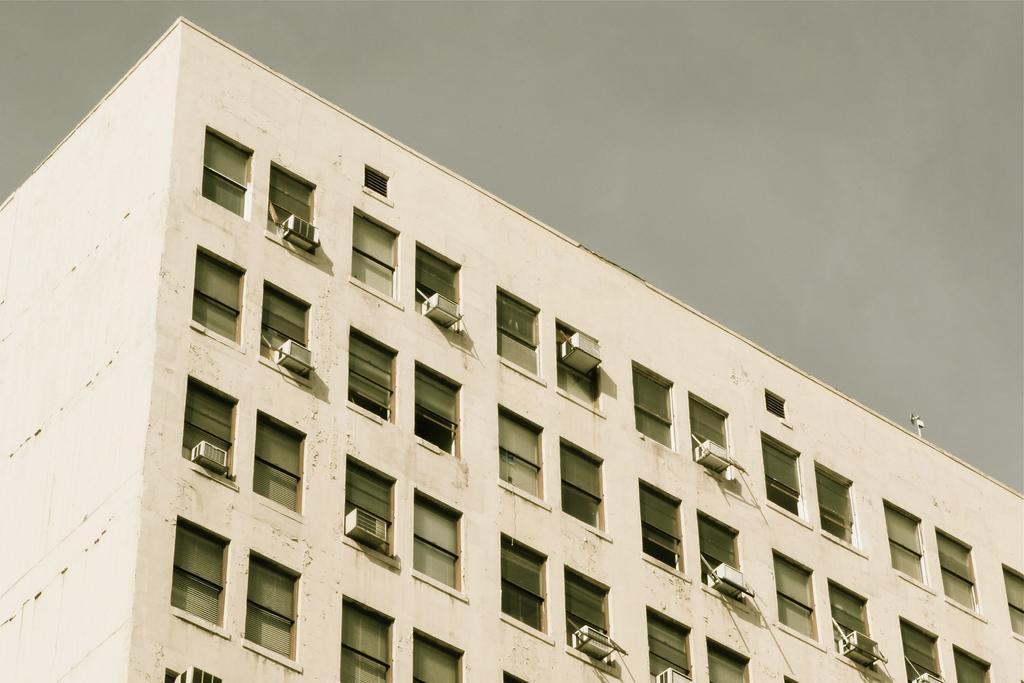In one or two sentences, can you explain what this image depicts? This image is taken outdoors. At the top of the image there is the sky with walls, windows and a roof. There are many air conditioners. 